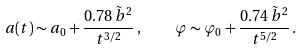Convert formula to latex. <formula><loc_0><loc_0><loc_500><loc_500>a ( t ) \sim a _ { 0 } + \frac { 0 . 7 8 \, \tilde { b } ^ { 2 } } { t ^ { 3 / 2 } } \, , \quad \varphi \sim \varphi _ { 0 } + \frac { 0 . 7 4 \, \tilde { b } ^ { 2 } } { t ^ { 5 / 2 } } \, .</formula> 